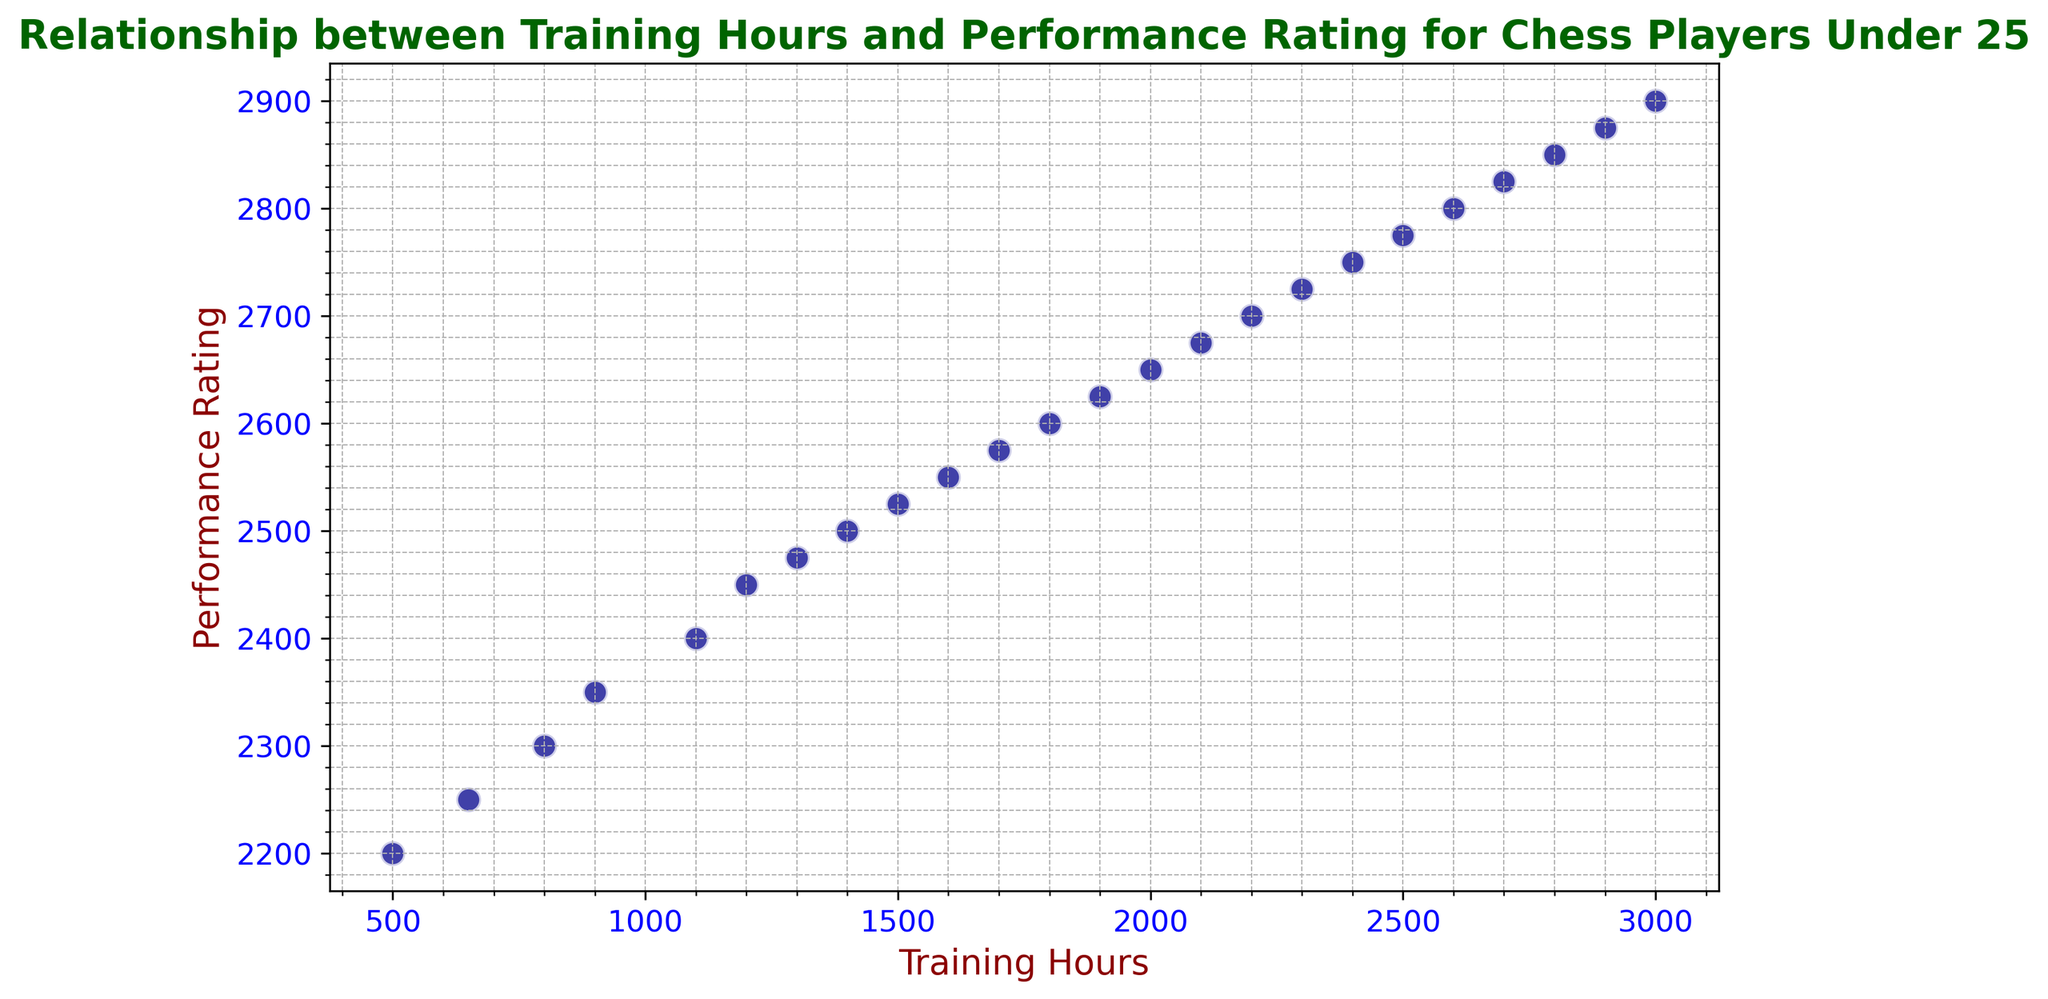What is the highest performance rating in the plot? The highest performance rating visible in the scatter plot can be determined directly by identifying the topmost data point on the vertical axis. The axis representing performance rating has its maximum point at 2900.
Answer: 2900 How many training hours correspond to a performance rating of 2500? To find the training hours corresponding to a specific performance rating, locate the point where the performance rating is 2500 on the vertical axis and trace horizontally to the respective training hours on the horizontal axis. The point where the performance rating is 2500 shows 1400 training hours.
Answer: 1400 What is the average performance rating for players training between 1000 to 2000 hours? First, identify the data points corresponding to training hours between 1000 to 2000. The ratings for these points are 2400, 2450, 2475, 2500, 2525, 2550, 2575, 2600, 2625, and 2650. Sum them up (2400 + 2450 + 2475 + 2500 + 2525 + 2550 + 2575 + 2600 + 2625 + 2650 = 25450). Divide by 10 (the number of points).
Answer: 2545 Compare the performance rating improvement from training 500 hours to training 1000 hours. Identify the performance ratings at 500 and 1000 training hours: 2200 and 2400 respectively. Subtract the performance rating at 500 hours from the rating at 1000 hours (2400 - 2200).
Answer: 200 How does the performance rating change when increasing training hours from 1500 to 2000? Identify the performance ratings at 1500 and 2000 hours: 2525 and 2650 respectively. The change in performance rating is calculated as the difference between the two (2650 - 2525).
Answer: 125 What training hours do you need to reach a performance rating of 2800? Locate the point where the vertical axis (performance rating) reaches 2800 and find the corresponding training hours on the horizontal axis. The point where 2800 is achieved corresponds to 2600 training hours.
Answer: 2600 What is the overall trend observed in the relationship between training hours and performance rating? The visual trend in the scatter plot shows a positive correlation where performance rating increases as the number of training hours increases. This indicates a general upward trend, with more training hours contributing to higher performance ratings.
Answer: Positive correlation What are the performance ratings at 900 and 1900 training hours? Identify the points for 900 and 1900 hours on the horizontal axis and trace them vertically to their corresponding performance ratings. At 900 hours, the rating is 2350, and at 1900 hours, the rating is 2625.
Answer: 2350 and 2625 Calculate the difference in performance rating improvement between training 1200 hours and 1800 hours. Identify the performance ratings at 1200 and 1800 hours: 2450 and 2600 respectively. The improvement is the difference between these two ratings (2600 - 2450).
Answer: 150 How many increments of 300 training hours are seen in the plot? To find the number of increments of 300 training hours, count the number of intervals of 300 between the minimum and maximum training hours (500 to 3000). These are: 800, 1100, 1400, 1700, 2000, 2300, 2600, and 2900 – a total of 8 increments.
Answer: 8 